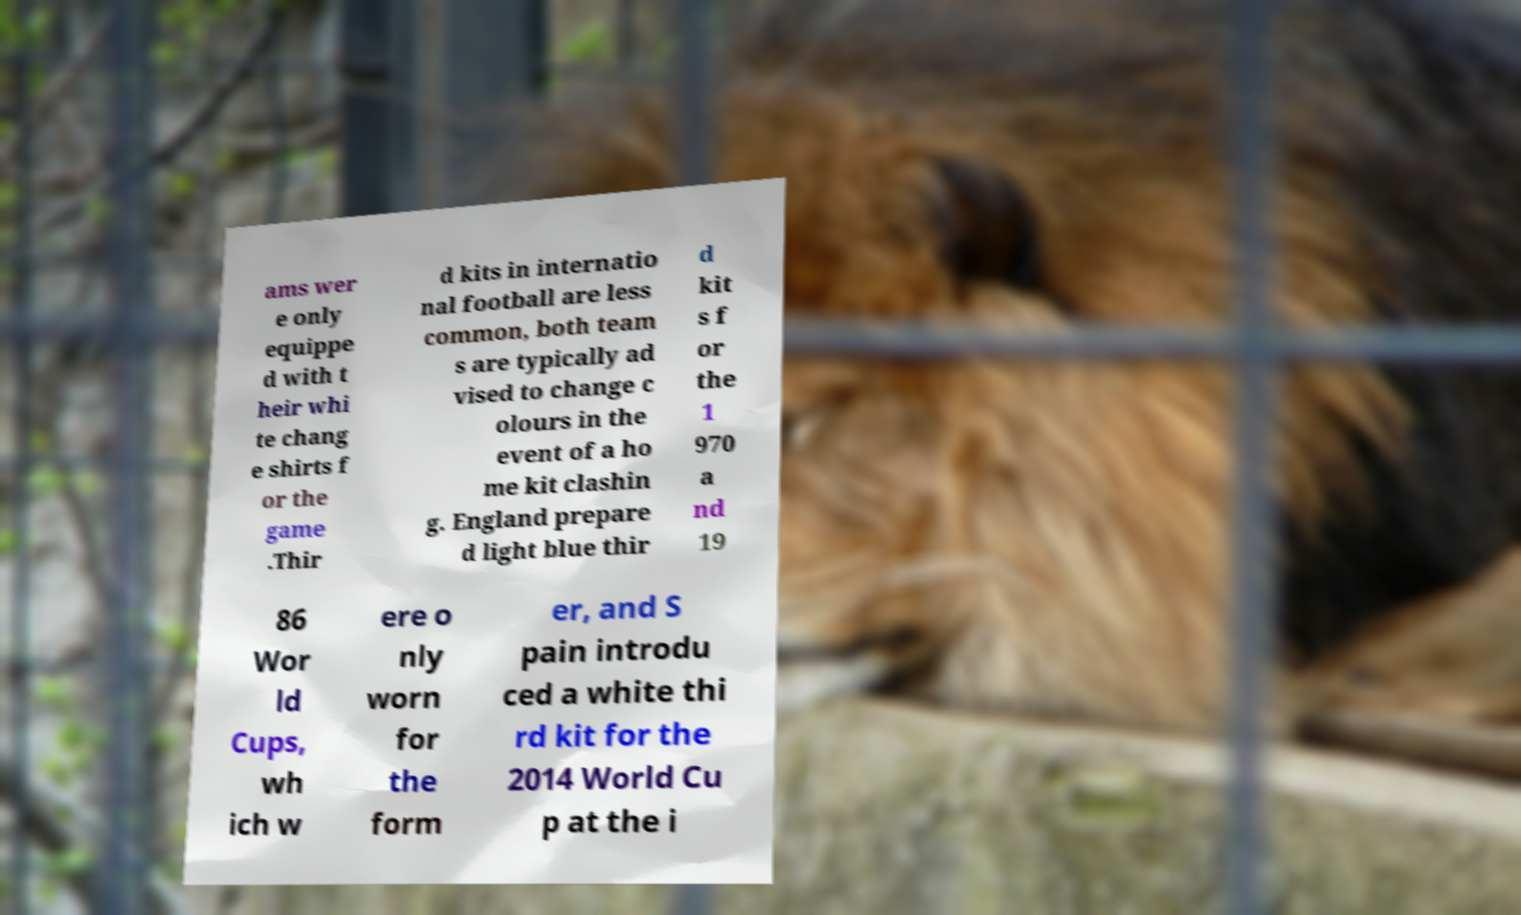What messages or text are displayed in this image? I need them in a readable, typed format. ams wer e only equippe d with t heir whi te chang e shirts f or the game .Thir d kits in internatio nal football are less common, both team s are typically ad vised to change c olours in the event of a ho me kit clashin g. England prepare d light blue thir d kit s f or the 1 970 a nd 19 86 Wor ld Cups, wh ich w ere o nly worn for the form er, and S pain introdu ced a white thi rd kit for the 2014 World Cu p at the i 